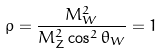Convert formula to latex. <formula><loc_0><loc_0><loc_500><loc_500>\rho = \frac { M _ { W } ^ { 2 } } { M _ { Z } ^ { 2 } \cos ^ { 2 } \theta _ { W } } = 1</formula> 